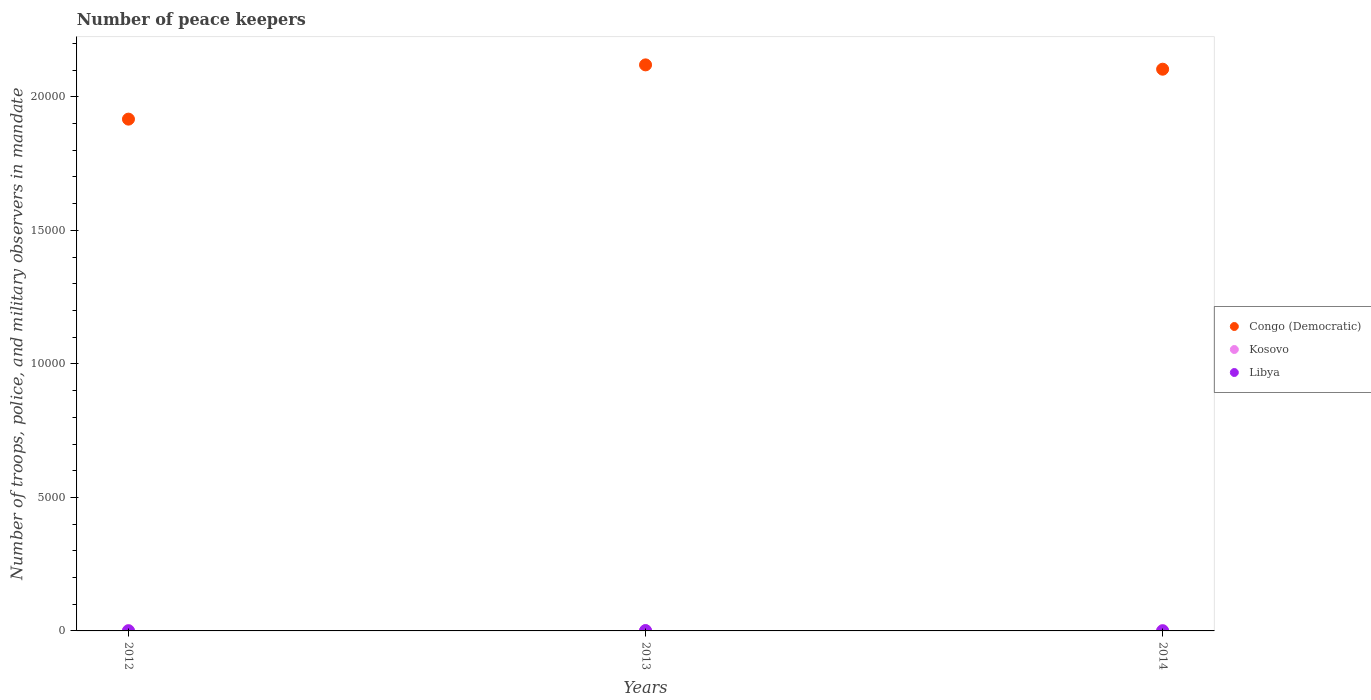How many different coloured dotlines are there?
Give a very brief answer. 3. Is the number of dotlines equal to the number of legend labels?
Provide a short and direct response. Yes. What is the number of peace keepers in in Congo (Democratic) in 2014?
Provide a succinct answer. 2.10e+04. Across all years, what is the maximum number of peace keepers in in Libya?
Offer a very short reply. 11. Across all years, what is the minimum number of peace keepers in in Kosovo?
Keep it short and to the point. 14. In which year was the number of peace keepers in in Libya maximum?
Offer a very short reply. 2013. In which year was the number of peace keepers in in Kosovo minimum?
Provide a succinct answer. 2013. What is the total number of peace keepers in in Congo (Democratic) in the graph?
Offer a very short reply. 6.14e+04. What is the difference between the number of peace keepers in in Kosovo in 2013 and the number of peace keepers in in Congo (Democratic) in 2012?
Make the answer very short. -1.92e+04. What is the average number of peace keepers in in Congo (Democratic) per year?
Provide a short and direct response. 2.05e+04. In the year 2012, what is the difference between the number of peace keepers in in Libya and number of peace keepers in in Kosovo?
Provide a short and direct response. -14. In how many years, is the number of peace keepers in in Kosovo greater than 12000?
Provide a short and direct response. 0. What is the ratio of the number of peace keepers in in Libya in 2012 to that in 2014?
Ensure brevity in your answer.  1. Is the difference between the number of peace keepers in in Libya in 2013 and 2014 greater than the difference between the number of peace keepers in in Kosovo in 2013 and 2014?
Your answer should be very brief. Yes. What is the difference between the highest and the second highest number of peace keepers in in Congo (Democratic)?
Make the answer very short. 162. What is the difference between the highest and the lowest number of peace keepers in in Kosovo?
Provide a succinct answer. 2. Is the sum of the number of peace keepers in in Congo (Democratic) in 2012 and 2014 greater than the maximum number of peace keepers in in Libya across all years?
Your answer should be compact. Yes. Is it the case that in every year, the sum of the number of peace keepers in in Congo (Democratic) and number of peace keepers in in Kosovo  is greater than the number of peace keepers in in Libya?
Provide a short and direct response. Yes. Is the number of peace keepers in in Congo (Democratic) strictly greater than the number of peace keepers in in Kosovo over the years?
Provide a short and direct response. Yes. Is the number of peace keepers in in Kosovo strictly less than the number of peace keepers in in Congo (Democratic) over the years?
Provide a short and direct response. Yes. Are the values on the major ticks of Y-axis written in scientific E-notation?
Offer a very short reply. No. Does the graph contain grids?
Your response must be concise. No. How are the legend labels stacked?
Provide a succinct answer. Vertical. What is the title of the graph?
Your answer should be compact. Number of peace keepers. Does "Somalia" appear as one of the legend labels in the graph?
Your answer should be very brief. No. What is the label or title of the Y-axis?
Your answer should be compact. Number of troops, police, and military observers in mandate. What is the Number of troops, police, and military observers in mandate of Congo (Democratic) in 2012?
Give a very brief answer. 1.92e+04. What is the Number of troops, police, and military observers in mandate in Congo (Democratic) in 2013?
Keep it short and to the point. 2.12e+04. What is the Number of troops, police, and military observers in mandate in Kosovo in 2013?
Keep it short and to the point. 14. What is the Number of troops, police, and military observers in mandate of Congo (Democratic) in 2014?
Provide a short and direct response. 2.10e+04. What is the Number of troops, police, and military observers in mandate in Kosovo in 2014?
Make the answer very short. 16. What is the Number of troops, police, and military observers in mandate in Libya in 2014?
Provide a succinct answer. 2. Across all years, what is the maximum Number of troops, police, and military observers in mandate of Congo (Democratic)?
Your response must be concise. 2.12e+04. Across all years, what is the maximum Number of troops, police, and military observers in mandate of Kosovo?
Provide a short and direct response. 16. Across all years, what is the maximum Number of troops, police, and military observers in mandate of Libya?
Keep it short and to the point. 11. Across all years, what is the minimum Number of troops, police, and military observers in mandate of Congo (Democratic)?
Your answer should be very brief. 1.92e+04. What is the total Number of troops, police, and military observers in mandate of Congo (Democratic) in the graph?
Keep it short and to the point. 6.14e+04. What is the total Number of troops, police, and military observers in mandate of Kosovo in the graph?
Your answer should be compact. 46. What is the total Number of troops, police, and military observers in mandate in Libya in the graph?
Offer a very short reply. 15. What is the difference between the Number of troops, police, and military observers in mandate of Congo (Democratic) in 2012 and that in 2013?
Your answer should be compact. -2032. What is the difference between the Number of troops, police, and military observers in mandate of Kosovo in 2012 and that in 2013?
Keep it short and to the point. 2. What is the difference between the Number of troops, police, and military observers in mandate of Libya in 2012 and that in 2013?
Make the answer very short. -9. What is the difference between the Number of troops, police, and military observers in mandate of Congo (Democratic) in 2012 and that in 2014?
Your answer should be very brief. -1870. What is the difference between the Number of troops, police, and military observers in mandate in Libya in 2012 and that in 2014?
Your answer should be compact. 0. What is the difference between the Number of troops, police, and military observers in mandate in Congo (Democratic) in 2013 and that in 2014?
Provide a succinct answer. 162. What is the difference between the Number of troops, police, and military observers in mandate in Kosovo in 2013 and that in 2014?
Offer a terse response. -2. What is the difference between the Number of troops, police, and military observers in mandate in Libya in 2013 and that in 2014?
Give a very brief answer. 9. What is the difference between the Number of troops, police, and military observers in mandate in Congo (Democratic) in 2012 and the Number of troops, police, and military observers in mandate in Kosovo in 2013?
Give a very brief answer. 1.92e+04. What is the difference between the Number of troops, police, and military observers in mandate of Congo (Democratic) in 2012 and the Number of troops, police, and military observers in mandate of Libya in 2013?
Provide a short and direct response. 1.92e+04. What is the difference between the Number of troops, police, and military observers in mandate of Congo (Democratic) in 2012 and the Number of troops, police, and military observers in mandate of Kosovo in 2014?
Your response must be concise. 1.92e+04. What is the difference between the Number of troops, police, and military observers in mandate of Congo (Democratic) in 2012 and the Number of troops, police, and military observers in mandate of Libya in 2014?
Make the answer very short. 1.92e+04. What is the difference between the Number of troops, police, and military observers in mandate of Congo (Democratic) in 2013 and the Number of troops, police, and military observers in mandate of Kosovo in 2014?
Provide a short and direct response. 2.12e+04. What is the difference between the Number of troops, police, and military observers in mandate of Congo (Democratic) in 2013 and the Number of troops, police, and military observers in mandate of Libya in 2014?
Your response must be concise. 2.12e+04. What is the difference between the Number of troops, police, and military observers in mandate of Kosovo in 2013 and the Number of troops, police, and military observers in mandate of Libya in 2014?
Keep it short and to the point. 12. What is the average Number of troops, police, and military observers in mandate of Congo (Democratic) per year?
Ensure brevity in your answer.  2.05e+04. What is the average Number of troops, police, and military observers in mandate in Kosovo per year?
Ensure brevity in your answer.  15.33. What is the average Number of troops, police, and military observers in mandate of Libya per year?
Keep it short and to the point. 5. In the year 2012, what is the difference between the Number of troops, police, and military observers in mandate of Congo (Democratic) and Number of troops, police, and military observers in mandate of Kosovo?
Ensure brevity in your answer.  1.92e+04. In the year 2012, what is the difference between the Number of troops, police, and military observers in mandate of Congo (Democratic) and Number of troops, police, and military observers in mandate of Libya?
Give a very brief answer. 1.92e+04. In the year 2012, what is the difference between the Number of troops, police, and military observers in mandate of Kosovo and Number of troops, police, and military observers in mandate of Libya?
Provide a succinct answer. 14. In the year 2013, what is the difference between the Number of troops, police, and military observers in mandate in Congo (Democratic) and Number of troops, police, and military observers in mandate in Kosovo?
Ensure brevity in your answer.  2.12e+04. In the year 2013, what is the difference between the Number of troops, police, and military observers in mandate in Congo (Democratic) and Number of troops, police, and military observers in mandate in Libya?
Your answer should be very brief. 2.12e+04. In the year 2014, what is the difference between the Number of troops, police, and military observers in mandate in Congo (Democratic) and Number of troops, police, and military observers in mandate in Kosovo?
Provide a succinct answer. 2.10e+04. In the year 2014, what is the difference between the Number of troops, police, and military observers in mandate of Congo (Democratic) and Number of troops, police, and military observers in mandate of Libya?
Give a very brief answer. 2.10e+04. What is the ratio of the Number of troops, police, and military observers in mandate in Congo (Democratic) in 2012 to that in 2013?
Provide a short and direct response. 0.9. What is the ratio of the Number of troops, police, and military observers in mandate in Kosovo in 2012 to that in 2013?
Ensure brevity in your answer.  1.14. What is the ratio of the Number of troops, police, and military observers in mandate of Libya in 2012 to that in 2013?
Your answer should be compact. 0.18. What is the ratio of the Number of troops, police, and military observers in mandate of Congo (Democratic) in 2012 to that in 2014?
Your answer should be very brief. 0.91. What is the ratio of the Number of troops, police, and military observers in mandate in Congo (Democratic) in 2013 to that in 2014?
Your answer should be very brief. 1.01. What is the ratio of the Number of troops, police, and military observers in mandate in Kosovo in 2013 to that in 2014?
Give a very brief answer. 0.88. What is the difference between the highest and the second highest Number of troops, police, and military observers in mandate in Congo (Democratic)?
Give a very brief answer. 162. What is the difference between the highest and the second highest Number of troops, police, and military observers in mandate of Libya?
Offer a very short reply. 9. What is the difference between the highest and the lowest Number of troops, police, and military observers in mandate in Congo (Democratic)?
Offer a terse response. 2032. What is the difference between the highest and the lowest Number of troops, police, and military observers in mandate of Kosovo?
Offer a terse response. 2. 